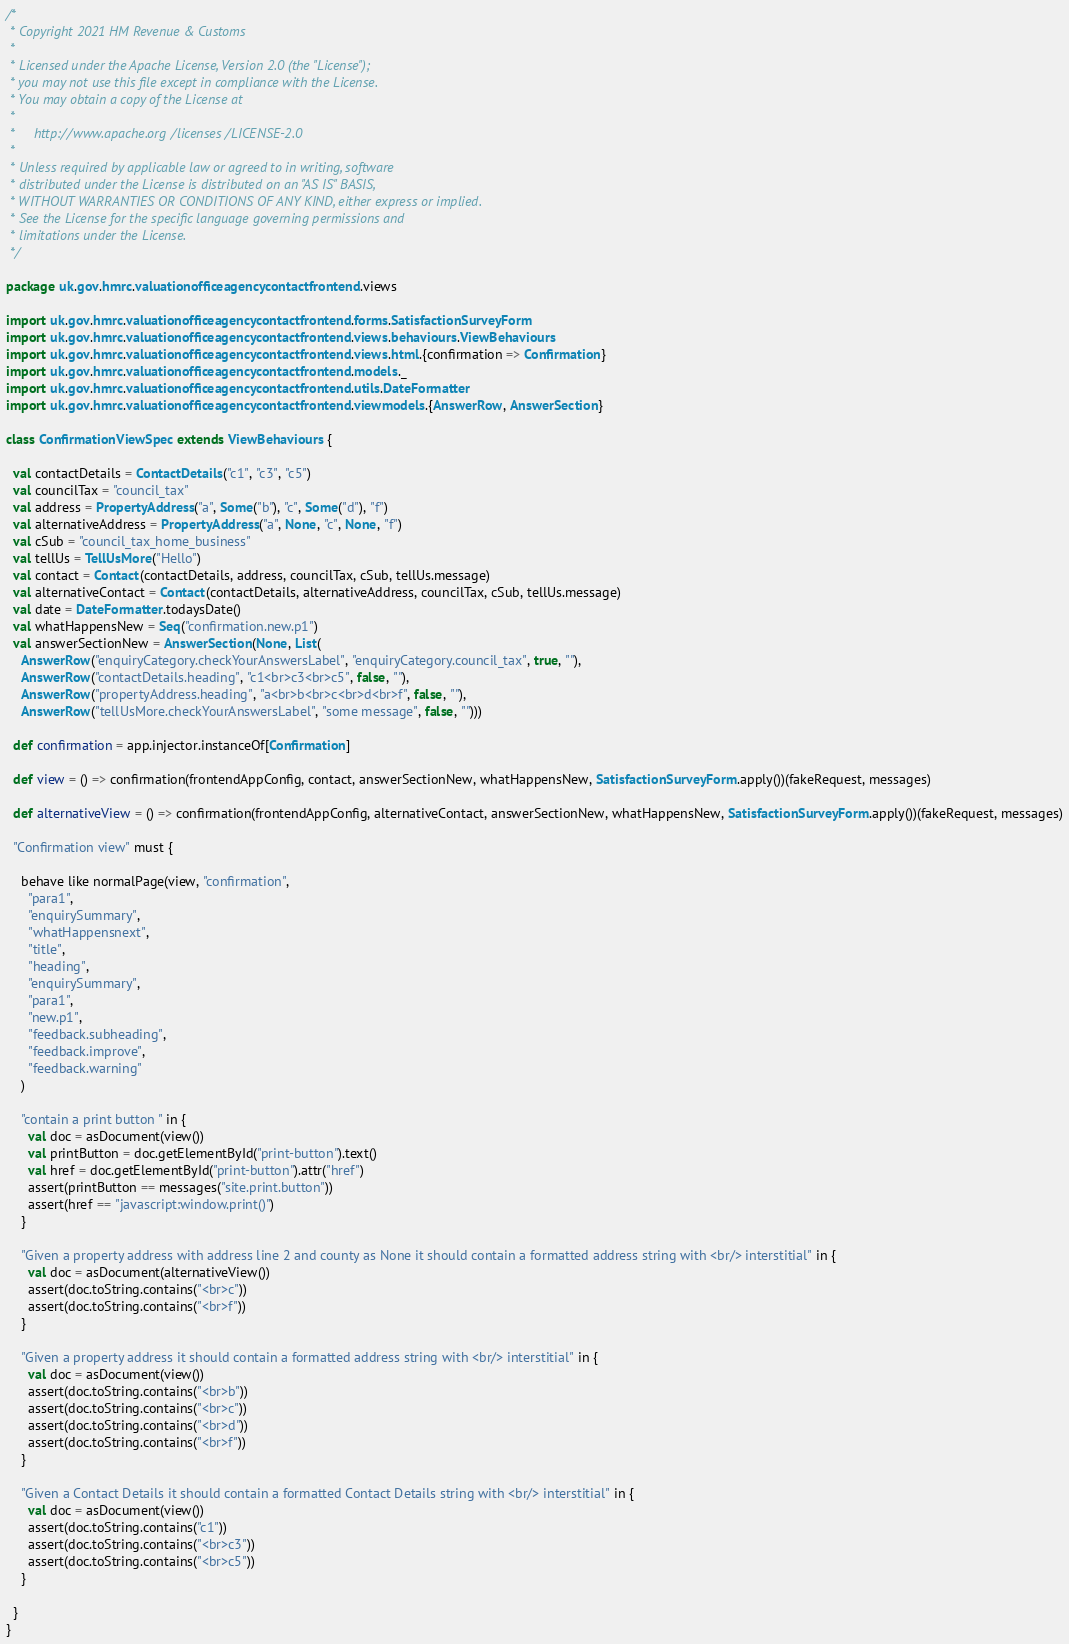Convert code to text. <code><loc_0><loc_0><loc_500><loc_500><_Scala_>/*
 * Copyright 2021 HM Revenue & Customs
 *
 * Licensed under the Apache License, Version 2.0 (the "License");
 * you may not use this file except in compliance with the License.
 * You may obtain a copy of the License at
 *
 *     http://www.apache.org/licenses/LICENSE-2.0
 *
 * Unless required by applicable law or agreed to in writing, software
 * distributed under the License is distributed on an "AS IS" BASIS,
 * WITHOUT WARRANTIES OR CONDITIONS OF ANY KIND, either express or implied.
 * See the License for the specific language governing permissions and
 * limitations under the License.
 */

package uk.gov.hmrc.valuationofficeagencycontactfrontend.views

import uk.gov.hmrc.valuationofficeagencycontactfrontend.forms.SatisfactionSurveyForm
import uk.gov.hmrc.valuationofficeagencycontactfrontend.views.behaviours.ViewBehaviours
import uk.gov.hmrc.valuationofficeagencycontactfrontend.views.html.{confirmation => Confirmation}
import uk.gov.hmrc.valuationofficeagencycontactfrontend.models._
import uk.gov.hmrc.valuationofficeagencycontactfrontend.utils.DateFormatter
import uk.gov.hmrc.valuationofficeagencycontactfrontend.viewmodels.{AnswerRow, AnswerSection}

class ConfirmationViewSpec extends ViewBehaviours {

  val contactDetails = ContactDetails("c1", "c3", "c5")
  val councilTax = "council_tax"
  val address = PropertyAddress("a", Some("b"), "c", Some("d"), "f")
  val alternativeAddress = PropertyAddress("a", None, "c", None, "f")
  val cSub = "council_tax_home_business"
  val tellUs = TellUsMore("Hello")
  val contact = Contact(contactDetails, address, councilTax, cSub, tellUs.message)
  val alternativeContact = Contact(contactDetails, alternativeAddress, councilTax, cSub, tellUs.message)
  val date = DateFormatter.todaysDate()
  val whatHappensNew = Seq("confirmation.new.p1")
  val answerSectionNew = AnswerSection(None, List(
    AnswerRow("enquiryCategory.checkYourAnswersLabel", "enquiryCategory.council_tax", true, ""),
    AnswerRow("contactDetails.heading", "c1<br>c3<br>c5", false, ""),
    AnswerRow("propertyAddress.heading", "a<br>b<br>c<br>d<br>f", false, ""),
    AnswerRow("tellUsMore.checkYourAnswersLabel", "some message", false, "")))

  def confirmation = app.injector.instanceOf[Confirmation]

  def view = () => confirmation(frontendAppConfig, contact, answerSectionNew, whatHappensNew, SatisfactionSurveyForm.apply())(fakeRequest, messages)

  def alternativeView = () => confirmation(frontendAppConfig, alternativeContact, answerSectionNew, whatHappensNew, SatisfactionSurveyForm.apply())(fakeRequest, messages)

  "Confirmation view" must {

    behave like normalPage(view, "confirmation",
      "para1",
      "enquirySummary",
      "whatHappensnext",
      "title",
      "heading",
      "enquirySummary",
      "para1",
      "new.p1",
      "feedback.subheading",
      "feedback.improve",
      "feedback.warning"
    )

    "contain a print button " in {
      val doc = asDocument(view())
      val printButton = doc.getElementById("print-button").text()
      val href = doc.getElementById("print-button").attr("href")
      assert(printButton == messages("site.print.button"))
      assert(href == "javascript:window.print()")
    }

    "Given a property address with address line 2 and county as None it should contain a formatted address string with <br/> interstitial" in {
      val doc = asDocument(alternativeView())
      assert(doc.toString.contains("<br>c"))
      assert(doc.toString.contains("<br>f"))
    }

    "Given a property address it should contain a formatted address string with <br/> interstitial" in {
      val doc = asDocument(view())
      assert(doc.toString.contains("<br>b"))
      assert(doc.toString.contains("<br>c"))
      assert(doc.toString.contains("<br>d"))
      assert(doc.toString.contains("<br>f"))
    }

    "Given a Contact Details it should contain a formatted Contact Details string with <br/> interstitial" in {
      val doc = asDocument(view())
      assert(doc.toString.contains("c1"))
      assert(doc.toString.contains("<br>c3"))
      assert(doc.toString.contains("<br>c5"))
    }

  }
}
</code> 